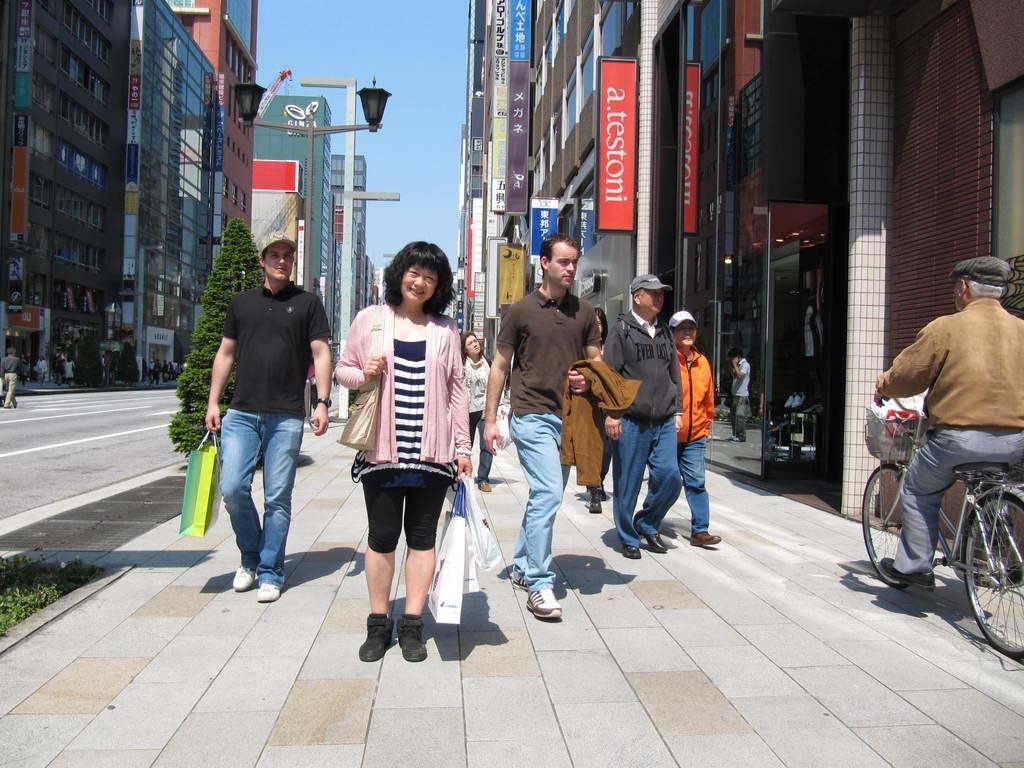Describe this image in one or two sentences. This is completely an outside view picture. Here on the road we can see few persons walking, holding carry bags in their hands. This man is holding a jacket. At the right side of the picture we can see a man riding a bicycle. At the right and left side of the picture we can see buildings. At the top we can see a clear blue sky and it seems like a sunny day. Near to this building we can few persons. This is a road. 